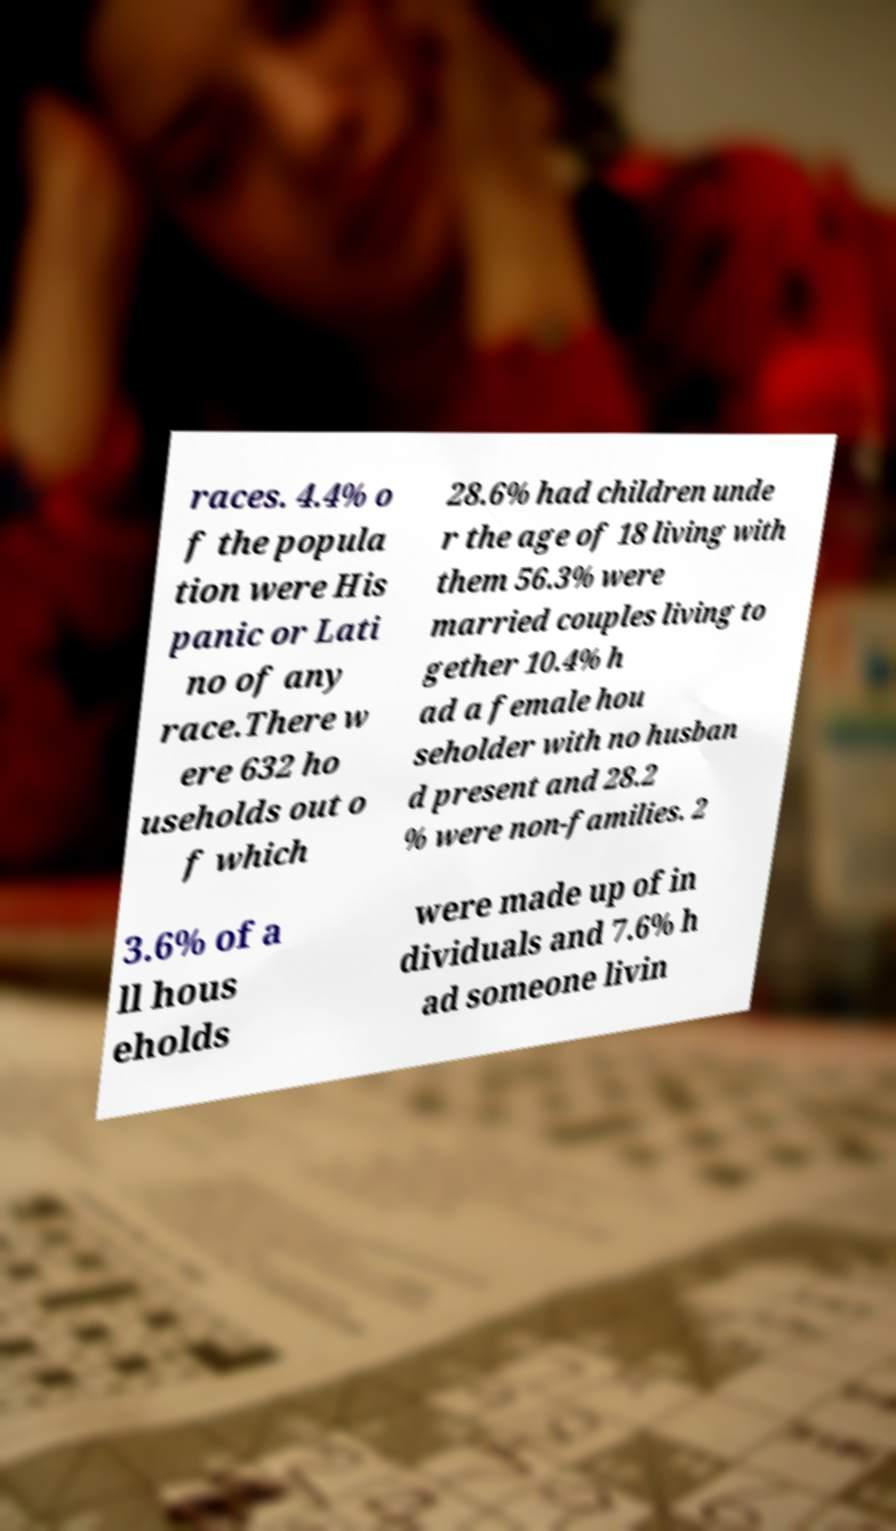There's text embedded in this image that I need extracted. Can you transcribe it verbatim? races. 4.4% o f the popula tion were His panic or Lati no of any race.There w ere 632 ho useholds out o f which 28.6% had children unde r the age of 18 living with them 56.3% were married couples living to gether 10.4% h ad a female hou seholder with no husban d present and 28.2 % were non-families. 2 3.6% of a ll hous eholds were made up of in dividuals and 7.6% h ad someone livin 